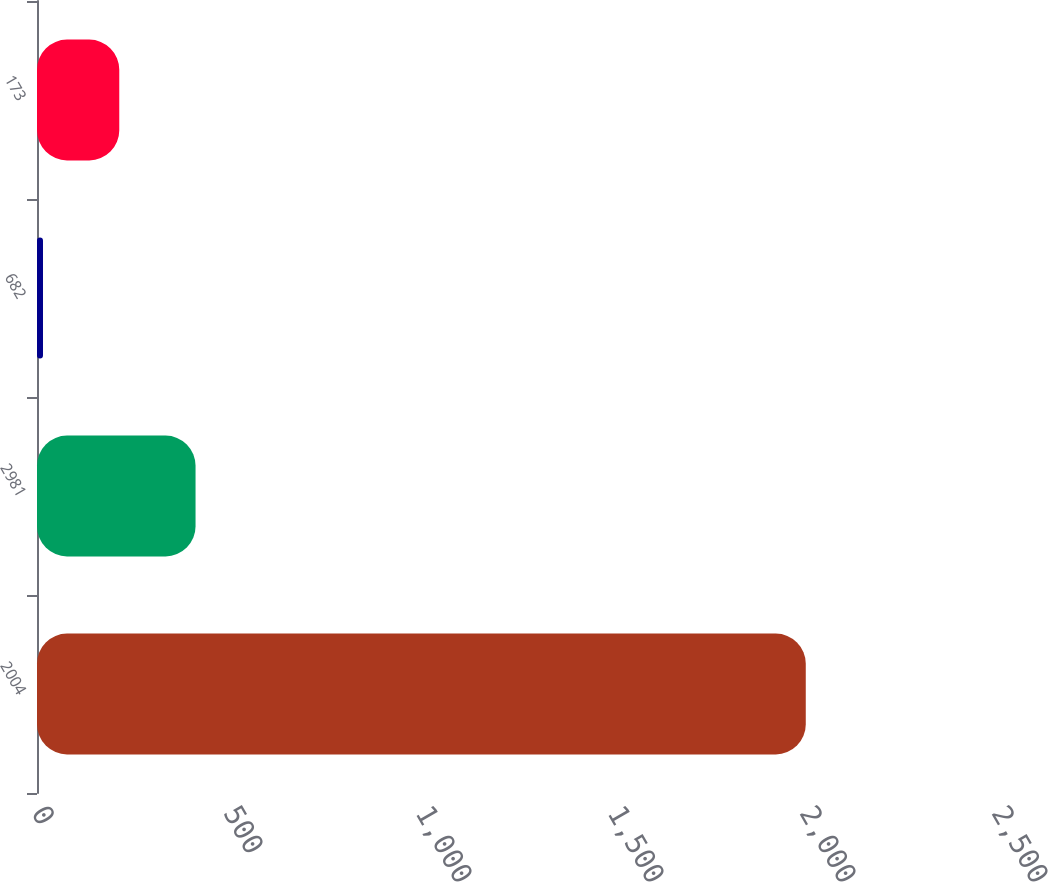Convert chart. <chart><loc_0><loc_0><loc_500><loc_500><bar_chart><fcel>2004<fcel>2981<fcel>682<fcel>173<nl><fcel>2002<fcel>412.88<fcel>15.6<fcel>214.24<nl></chart> 